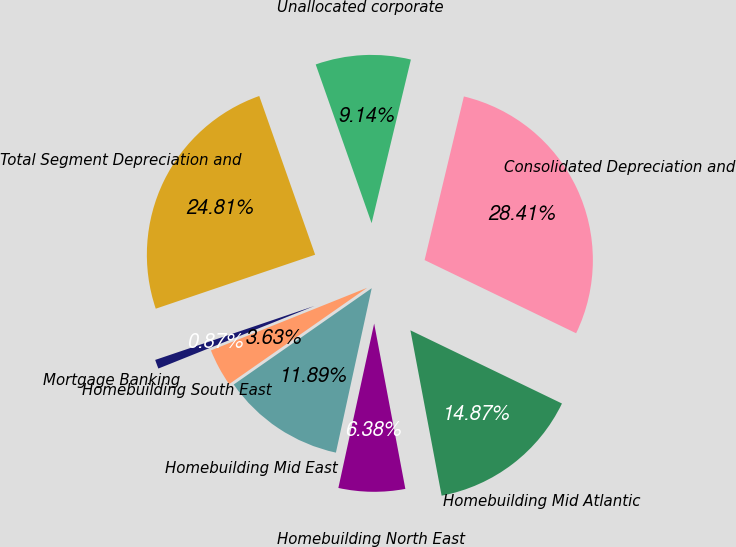<chart> <loc_0><loc_0><loc_500><loc_500><pie_chart><fcel>Homebuilding Mid Atlantic<fcel>Homebuilding North East<fcel>Homebuilding Mid East<fcel>Homebuilding South East<fcel>Mortgage Banking<fcel>Total Segment Depreciation and<fcel>Unallocated corporate<fcel>Consolidated Depreciation and<nl><fcel>14.87%<fcel>6.38%<fcel>11.89%<fcel>3.63%<fcel>0.87%<fcel>24.81%<fcel>9.14%<fcel>28.41%<nl></chart> 